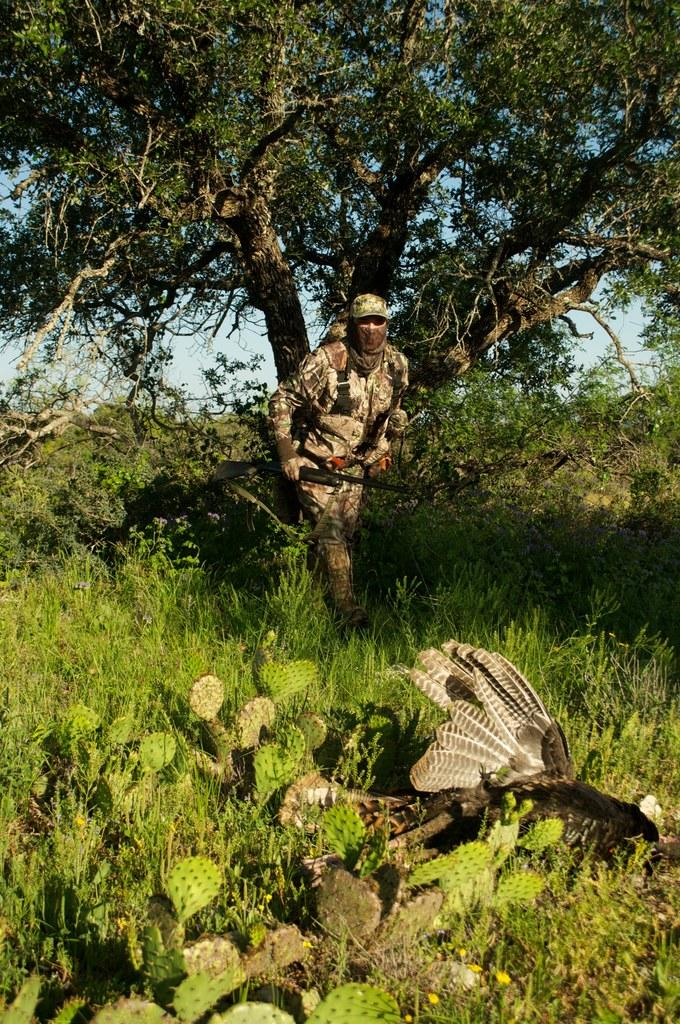What type of animal can be seen in the image? There is a bird in the image. What type of vegetation is present in the image? There is grass and a cactus plant on the ground in the image. What is the man in the image doing? The man is walking in the image and holding a gun in his hand. What can be seen in the background of the image? There are trees and the sky visible in the background of the image. How many doors are visible in the image? There are no doors present in the image. Can you describe the sheep in the image? There are no sheep present in the image. 